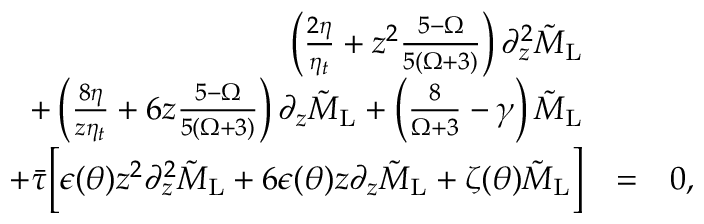<formula> <loc_0><loc_0><loc_500><loc_500>\begin{array} { r l r } { \left ( \frac { 2 \eta } { \eta _ { t } } + z ^ { 2 } \frac { 5 - \Omega } { 5 ( \Omega + 3 ) } \right ) \partial _ { z } ^ { 2 } \tilde { M } _ { L } } & \\ { + \left ( \frac { 8 \eta } { z \eta _ { t } } + 6 z \frac { 5 - \Omega } { 5 ( \Omega + 3 ) } \right ) \partial _ { z } \tilde { M } _ { L } + \left ( \frac { 8 } { \Omega + 3 } - \gamma \right ) \tilde { M } _ { L } } & \\ { + \ B a r { \tau } \left [ \epsilon ( \theta ) z ^ { 2 } \partial _ { z } ^ { 2 } \tilde { M } _ { L } + 6 \epsilon ( \theta ) z \partial _ { z } \tilde { M } _ { L } + \zeta ( \theta ) \tilde { M } _ { L } \right ] } & { = } & { 0 , } \end{array}</formula> 